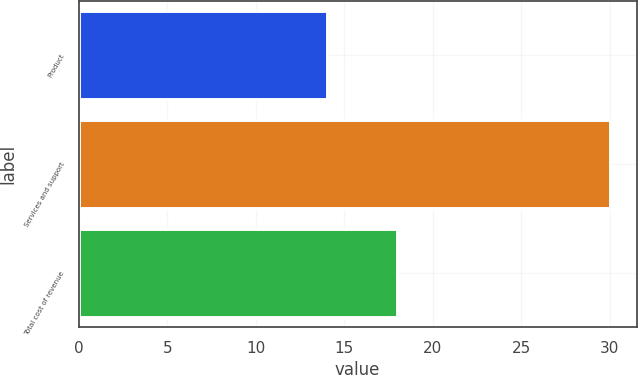Convert chart. <chart><loc_0><loc_0><loc_500><loc_500><bar_chart><fcel>Product<fcel>Services and support<fcel>Total cost of revenue<nl><fcel>14<fcel>30<fcel>18<nl></chart> 